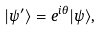Convert formula to latex. <formula><loc_0><loc_0><loc_500><loc_500>| \psi ^ { \prime } \rangle = e ^ { i \theta } | \psi \rangle ,</formula> 